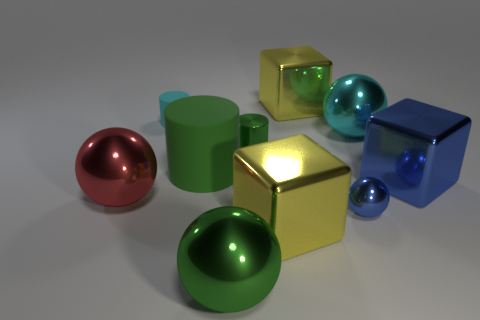Subtract 1 spheres. How many spheres are left? 3 Subtract all blocks. How many objects are left? 7 Add 8 cyan things. How many cyan things exist? 10 Subtract 1 cyan cylinders. How many objects are left? 9 Subtract all big brown cubes. Subtract all metal cylinders. How many objects are left? 9 Add 3 yellow metallic cubes. How many yellow metallic cubes are left? 5 